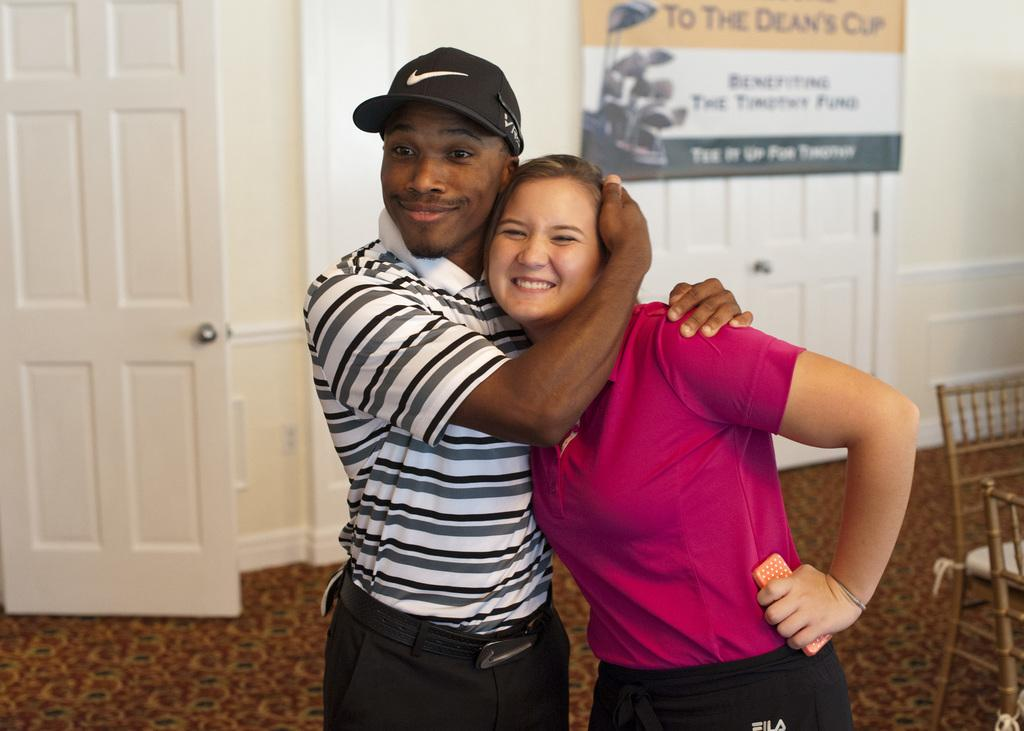Who are the two people in the image? There is a man and a lady standing in the center of the image. What can be seen on the right side of the image? There are chairs on the right side of the image. What is visible in the background of the image? There are doors and a board placed on a wall in the background of the image. What type of popcorn is the man attempting to bite in the image? There is no popcorn present in the image, and the man is not attempting to bite anything. 